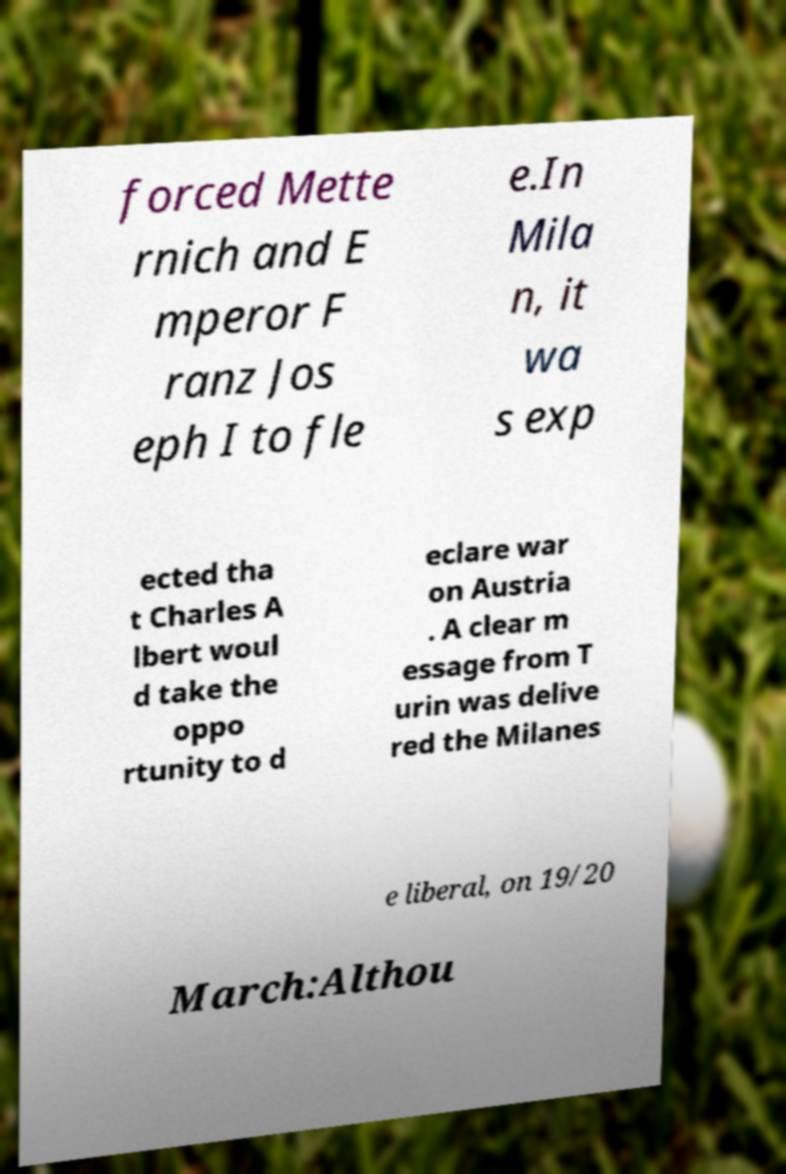What messages or text are displayed in this image? I need them in a readable, typed format. forced Mette rnich and E mperor F ranz Jos eph I to fle e.In Mila n, it wa s exp ected tha t Charles A lbert woul d take the oppo rtunity to d eclare war on Austria . A clear m essage from T urin was delive red the Milanes e liberal, on 19/20 March:Althou 